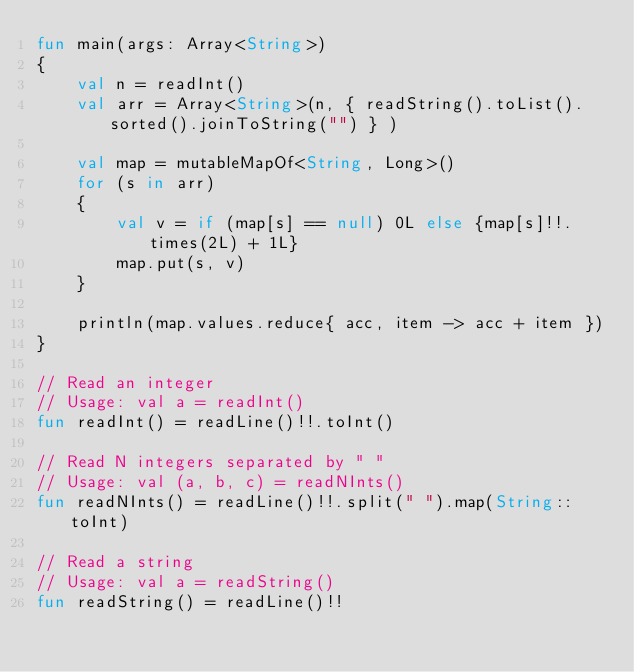<code> <loc_0><loc_0><loc_500><loc_500><_Kotlin_>fun main(args: Array<String>)
{
    val n = readInt()
    val arr = Array<String>(n, { readString().toList().sorted().joinToString("") } )

    val map = mutableMapOf<String, Long>()
    for (s in arr)
    {
        val v = if (map[s] == null) 0L else {map[s]!!.times(2L) + 1L}
        map.put(s, v)
    }

    println(map.values.reduce{ acc, item -> acc + item })
}

// Read an integer
// Usage: val a = readInt()
fun readInt() = readLine()!!.toInt()

// Read N integers separated by " "
// Usage: val (a, b, c) = readNInts()
fun readNInts() = readLine()!!.split(" ").map(String::toInt)

// Read a string
// Usage: val a = readString()
fun readString() = readLine()!!
</code> 